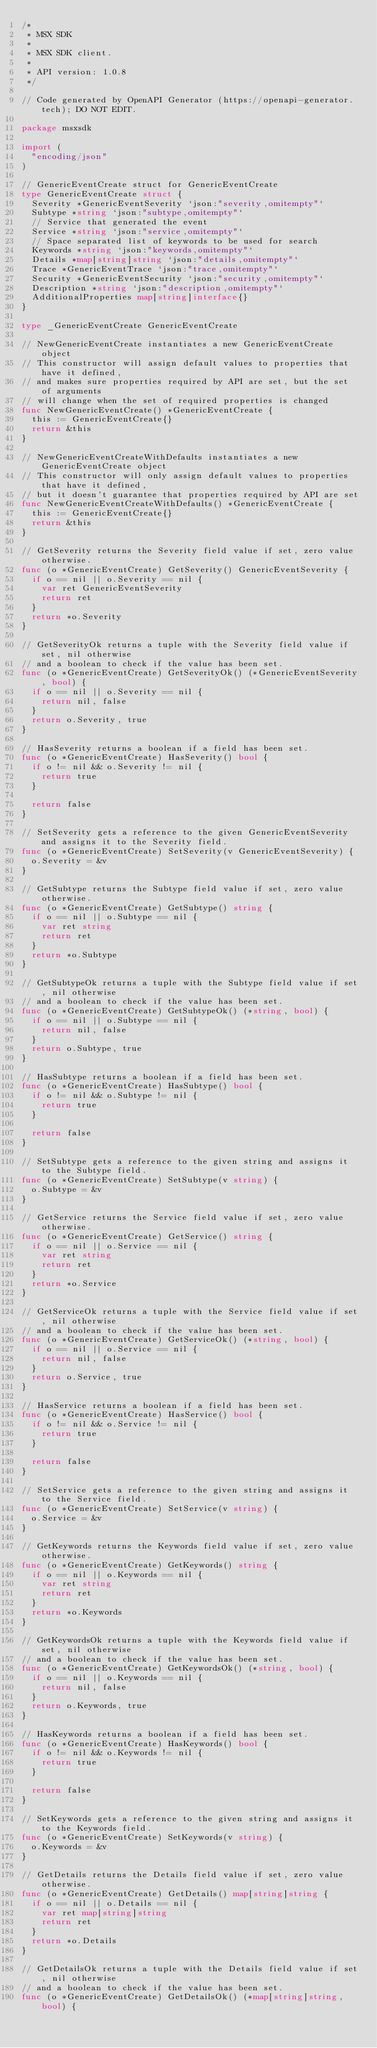<code> <loc_0><loc_0><loc_500><loc_500><_Go_>/*
 * MSX SDK
 *
 * MSX SDK client.
 *
 * API version: 1.0.8
 */

// Code generated by OpenAPI Generator (https://openapi-generator.tech); DO NOT EDIT.

package msxsdk

import (
	"encoding/json"
)

// GenericEventCreate struct for GenericEventCreate
type GenericEventCreate struct {
	Severity *GenericEventSeverity `json:"severity,omitempty"`
	Subtype *string `json:"subtype,omitempty"`
	// Service that generated the event
	Service *string `json:"service,omitempty"`
	// Space separated list of keywords to be used for search
	Keywords *string `json:"keywords,omitempty"`
	Details *map[string]string `json:"details,omitempty"`
	Trace *GenericEventTrace `json:"trace,omitempty"`
	Security *GenericEventSecurity `json:"security,omitempty"`
	Description *string `json:"description,omitempty"`
	AdditionalProperties map[string]interface{}
}

type _GenericEventCreate GenericEventCreate

// NewGenericEventCreate instantiates a new GenericEventCreate object
// This constructor will assign default values to properties that have it defined,
// and makes sure properties required by API are set, but the set of arguments
// will change when the set of required properties is changed
func NewGenericEventCreate() *GenericEventCreate {
	this := GenericEventCreate{}
	return &this
}

// NewGenericEventCreateWithDefaults instantiates a new GenericEventCreate object
// This constructor will only assign default values to properties that have it defined,
// but it doesn't guarantee that properties required by API are set
func NewGenericEventCreateWithDefaults() *GenericEventCreate {
	this := GenericEventCreate{}
	return &this
}

// GetSeverity returns the Severity field value if set, zero value otherwise.
func (o *GenericEventCreate) GetSeverity() GenericEventSeverity {
	if o == nil || o.Severity == nil {
		var ret GenericEventSeverity
		return ret
	}
	return *o.Severity
}

// GetSeverityOk returns a tuple with the Severity field value if set, nil otherwise
// and a boolean to check if the value has been set.
func (o *GenericEventCreate) GetSeverityOk() (*GenericEventSeverity, bool) {
	if o == nil || o.Severity == nil {
		return nil, false
	}
	return o.Severity, true
}

// HasSeverity returns a boolean if a field has been set.
func (o *GenericEventCreate) HasSeverity() bool {
	if o != nil && o.Severity != nil {
		return true
	}

	return false
}

// SetSeverity gets a reference to the given GenericEventSeverity and assigns it to the Severity field.
func (o *GenericEventCreate) SetSeverity(v GenericEventSeverity) {
	o.Severity = &v
}

// GetSubtype returns the Subtype field value if set, zero value otherwise.
func (o *GenericEventCreate) GetSubtype() string {
	if o == nil || o.Subtype == nil {
		var ret string
		return ret
	}
	return *o.Subtype
}

// GetSubtypeOk returns a tuple with the Subtype field value if set, nil otherwise
// and a boolean to check if the value has been set.
func (o *GenericEventCreate) GetSubtypeOk() (*string, bool) {
	if o == nil || o.Subtype == nil {
		return nil, false
	}
	return o.Subtype, true
}

// HasSubtype returns a boolean if a field has been set.
func (o *GenericEventCreate) HasSubtype() bool {
	if o != nil && o.Subtype != nil {
		return true
	}

	return false
}

// SetSubtype gets a reference to the given string and assigns it to the Subtype field.
func (o *GenericEventCreate) SetSubtype(v string) {
	o.Subtype = &v
}

// GetService returns the Service field value if set, zero value otherwise.
func (o *GenericEventCreate) GetService() string {
	if o == nil || o.Service == nil {
		var ret string
		return ret
	}
	return *o.Service
}

// GetServiceOk returns a tuple with the Service field value if set, nil otherwise
// and a boolean to check if the value has been set.
func (o *GenericEventCreate) GetServiceOk() (*string, bool) {
	if o == nil || o.Service == nil {
		return nil, false
	}
	return o.Service, true
}

// HasService returns a boolean if a field has been set.
func (o *GenericEventCreate) HasService() bool {
	if o != nil && o.Service != nil {
		return true
	}

	return false
}

// SetService gets a reference to the given string and assigns it to the Service field.
func (o *GenericEventCreate) SetService(v string) {
	o.Service = &v
}

// GetKeywords returns the Keywords field value if set, zero value otherwise.
func (o *GenericEventCreate) GetKeywords() string {
	if o == nil || o.Keywords == nil {
		var ret string
		return ret
	}
	return *o.Keywords
}

// GetKeywordsOk returns a tuple with the Keywords field value if set, nil otherwise
// and a boolean to check if the value has been set.
func (o *GenericEventCreate) GetKeywordsOk() (*string, bool) {
	if o == nil || o.Keywords == nil {
		return nil, false
	}
	return o.Keywords, true
}

// HasKeywords returns a boolean if a field has been set.
func (o *GenericEventCreate) HasKeywords() bool {
	if o != nil && o.Keywords != nil {
		return true
	}

	return false
}

// SetKeywords gets a reference to the given string and assigns it to the Keywords field.
func (o *GenericEventCreate) SetKeywords(v string) {
	o.Keywords = &v
}

// GetDetails returns the Details field value if set, zero value otherwise.
func (o *GenericEventCreate) GetDetails() map[string]string {
	if o == nil || o.Details == nil {
		var ret map[string]string
		return ret
	}
	return *o.Details
}

// GetDetailsOk returns a tuple with the Details field value if set, nil otherwise
// and a boolean to check if the value has been set.
func (o *GenericEventCreate) GetDetailsOk() (*map[string]string, bool) {</code> 